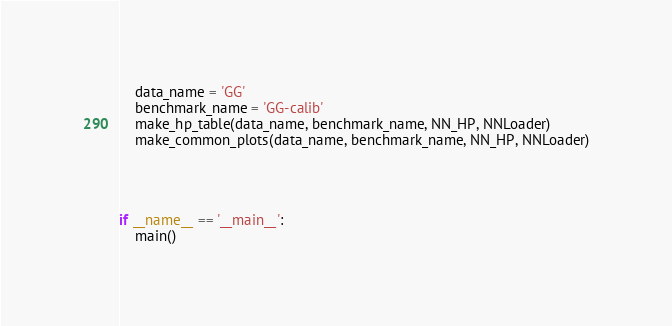Convert code to text. <code><loc_0><loc_0><loc_500><loc_500><_Python_>
    data_name = 'GG'
    benchmark_name = 'GG-calib'
    make_hp_table(data_name, benchmark_name, NN_HP, NNLoader)
    make_common_plots(data_name, benchmark_name, NN_HP, NNLoader)




if __name__ == '__main__':
    main()
</code> 